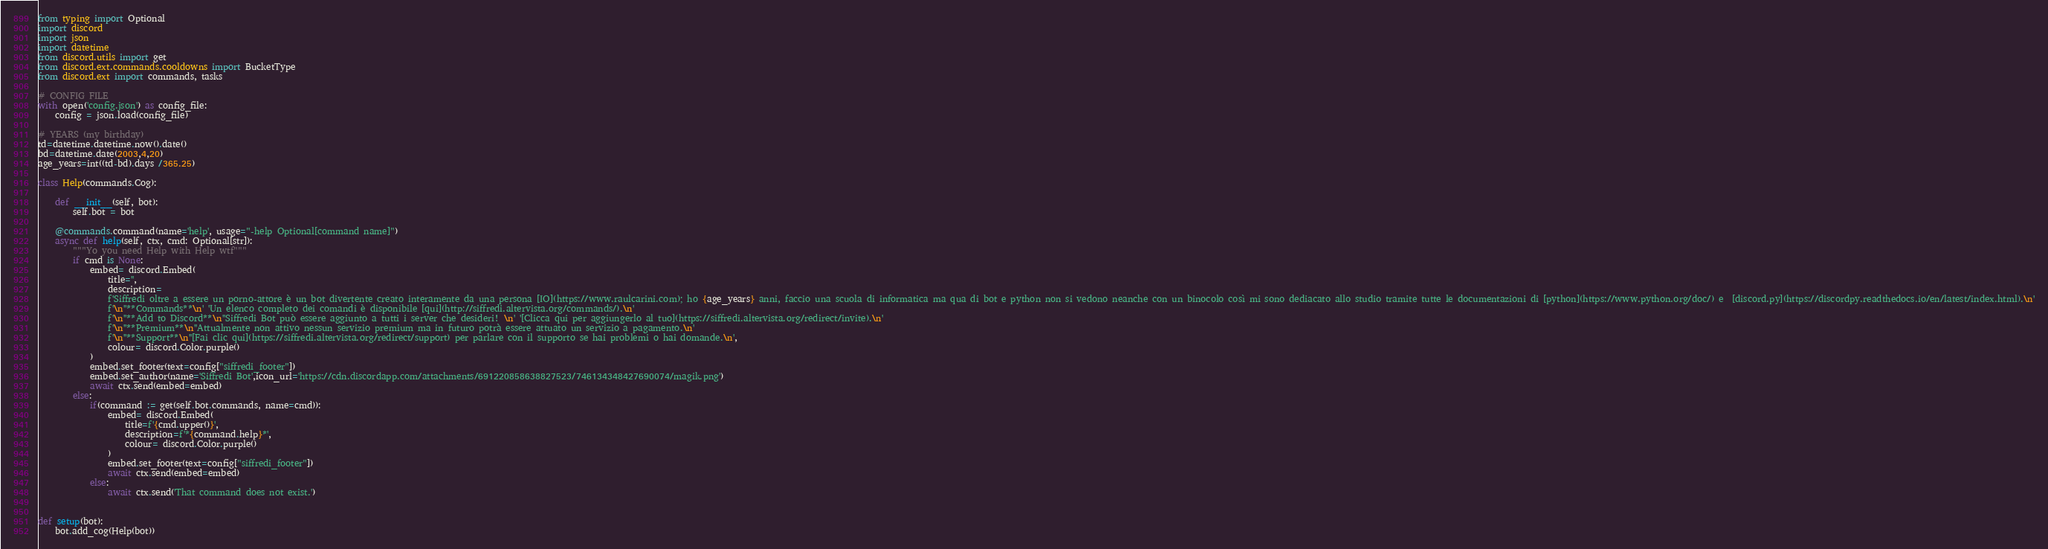Convert code to text. <code><loc_0><loc_0><loc_500><loc_500><_Python_>from typing import Optional
import discord
import json
import datetime
from discord.utils import get
from discord.ext.commands.cooldowns import BucketType
from discord.ext import commands, tasks

# CONFIG FILE
with open('config.json') as config_file:
    config = json.load(config_file)

# YEARS (my birthday)
td=datetime.datetime.now().date()
bd=datetime.date(2003,4,20)
age_years=int((td-bd).days /365.25)

class Help(commands.Cog):

    def __init__(self, bot):
        self.bot = bot

    @commands.command(name='help', usage="-help Optional[command name]")
    async def help(self, ctx, cmd: Optional[str]):
        """Yo you need Help with Help wtf"""
        if cmd is None:
            embed= discord.Embed(
                title='', 
                description= 
                f'Siffredi oltre a essere un porno-attore è un bot divertente creato interamente da una persona [IO](https://www.raulcarini.com); ho {age_years} anni, faccio una scuola di informatica ma qua di bot e python non si vedono neanche con un binocolo così mi sono dediacato allo studio tramite tutte le documentazioni di [python](https://www.python.org/doc/) e  [discord.py](https://discordpy.readthedocs.io/en/latest/index.html).\n'
                f'\n''**Commands**\n' 'Un elenco completo dei comandi è disponibile [qui](http://siffredi.altervista.org/commands/).\n'
                f'\n''**Add to Discord**\n''Siffredi Bot può essere aggiunto a tutti i server che desideri! \n' '[Clicca qui per aggiungerlo al tuo](https://siffredi.altervista.org/redirect/invite).\n'
                f'\n''**Premium**\n''Attualmente non attivo nessun servizio premium ma in futuro potrà essere attuato un servizio a pagamento.\n'
                f'\n''**Support**\n''[Fai clic qui](https://siffredi.altervista.org/redirect/support) per parlare con il supporto se hai problemi o hai domande.\n',
                colour= discord.Color.purple()
            )
            embed.set_footer(text=config["siffredi_footer"])
            embed.set_author(name='Siffredi Bot',icon_url='https://cdn.discordapp.com/attachments/691220858638827523/746134348427690074/magik.png')
            await ctx.send(embed=embed)
        else:
            if(command := get(self.bot.commands, name=cmd)):
                embed= discord.Embed(
                    title=f'{cmd.upper()}', 
                    description=f'*{command.help}*',
                    colour= discord.Color.purple()
                )
                embed.set_footer(text=config["siffredi_footer"])
                await ctx.send(embed=embed)
            else:
                await ctx.send('That command does not exist.')


def setup(bot):
    bot.add_cog(Help(bot))</code> 